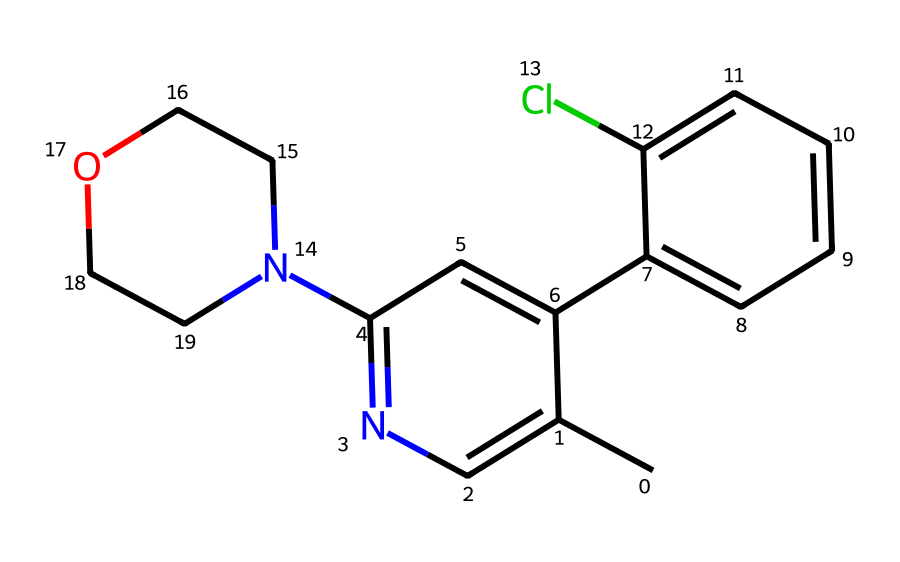What is the primary functional group in this chemical structure? The chemical contains a nitrogen atom within a heterocyclic ring, indicating the presence of an amine functional group. This is critical as amines often contribute to the properties of sedatives and anxiolytics.
Answer: amine How many carbon atoms are present in the molecule? By counting the carbon atoms in the SMILES representation, we find several carbon atoms forming the rings and chains. After thorough counting, the total comes to 18 carbon atoms.
Answer: 18 Is this chemical likely to be lipophilic or hydrophilic? The presence of multiple carbon chains and rings usually indicates lipophilicity, which is common among many sedatives and anxiolytics as they need to penetrate cellular membranes.
Answer: lipophilic What is the significance of the chlorine substituent in this structure? The chlorine substituent often enhances the lipophilicity and can affect the drug's interactions with receptors, influencing efficacy and potency in managing stress.
Answer: enhances lipophilicity Which part of the structure might interact with GABA receptors? The nitrogen atoms in the amine groups and the overall cyclic structure suggest potential interaction sites with GABA receptors, important for the sedative effects.
Answer: nitrogen atoms What type of drug classification does this structure belong to? Based on the analysis of functional groups and structure, it is classified as a sedative/anxiolytic drug, targeting stress and anxiety through its biochemical interactions.
Answer: sedative/anxiolytic 